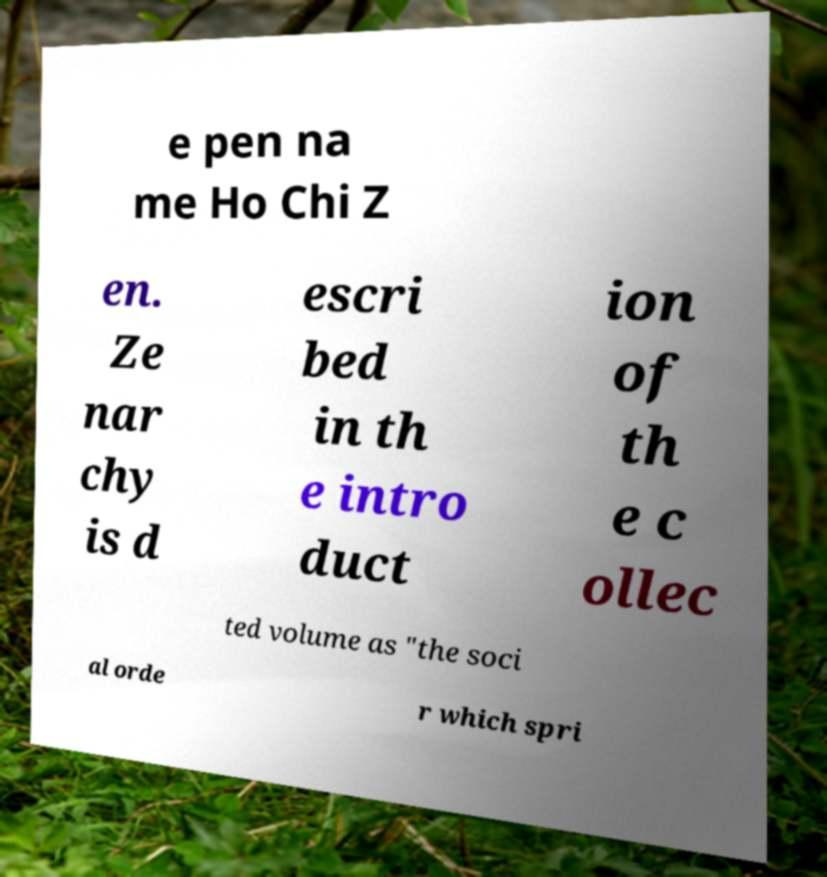What messages or text are displayed in this image? I need them in a readable, typed format. e pen na me Ho Chi Z en. Ze nar chy is d escri bed in th e intro duct ion of th e c ollec ted volume as "the soci al orde r which spri 